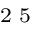<formula> <loc_0><loc_0><loc_500><loc_500>^ { 2 } 5</formula> 